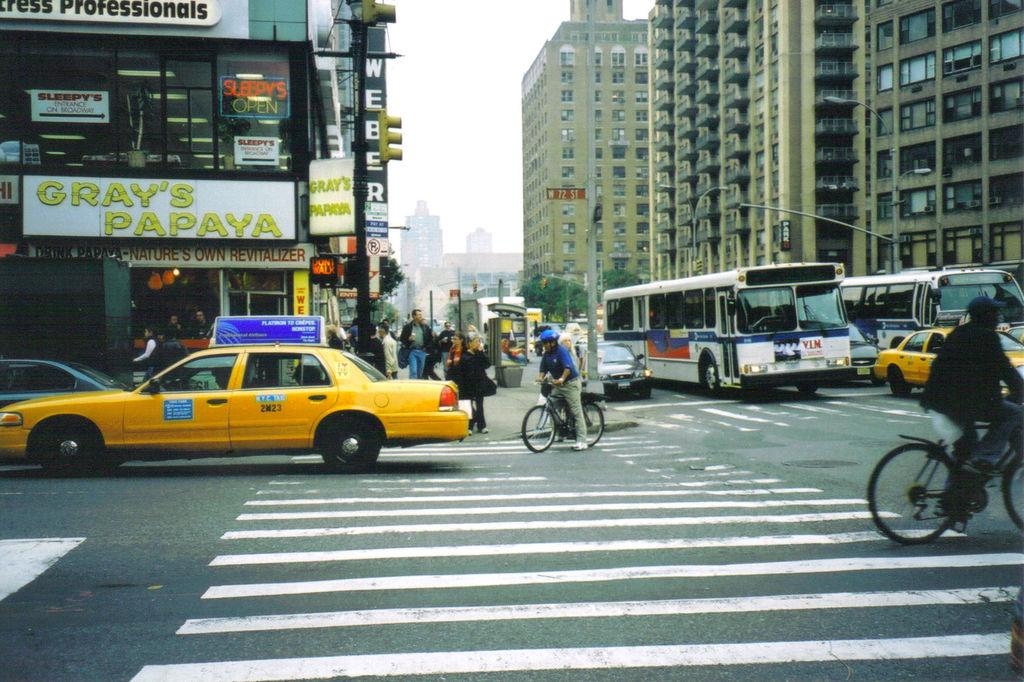<image>
Summarize the visual content of the image. A papaya store is on a city street corner. 